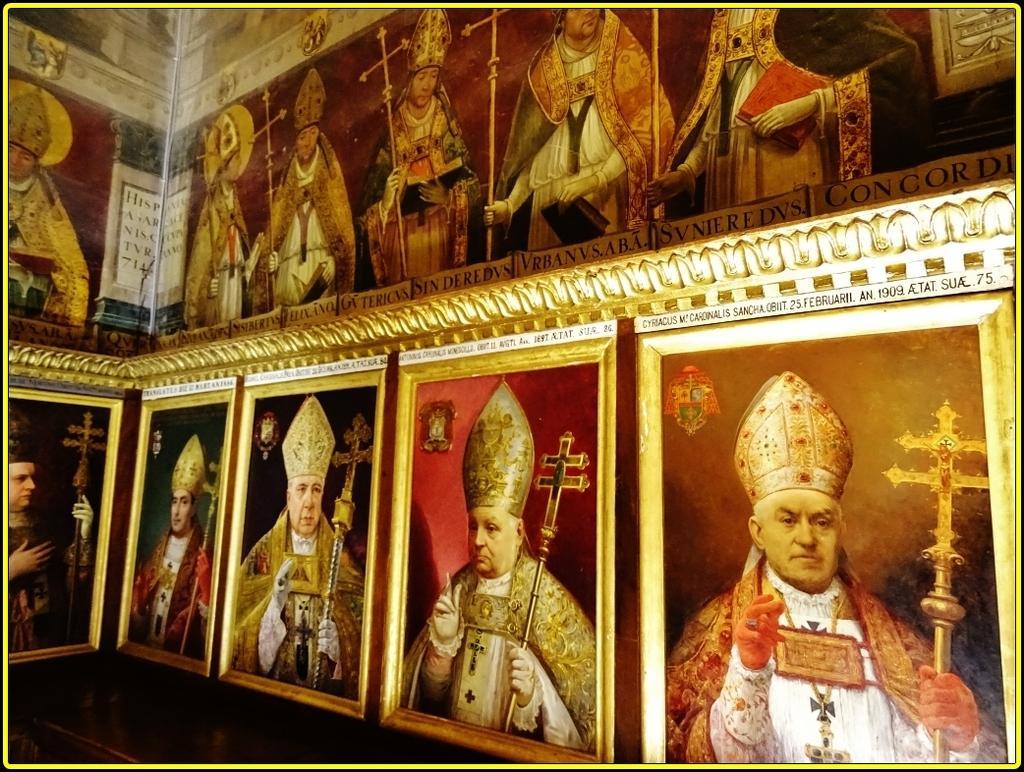Could you give a brief overview of what you see in this image? Here we can see frames, and pictures of persons. 